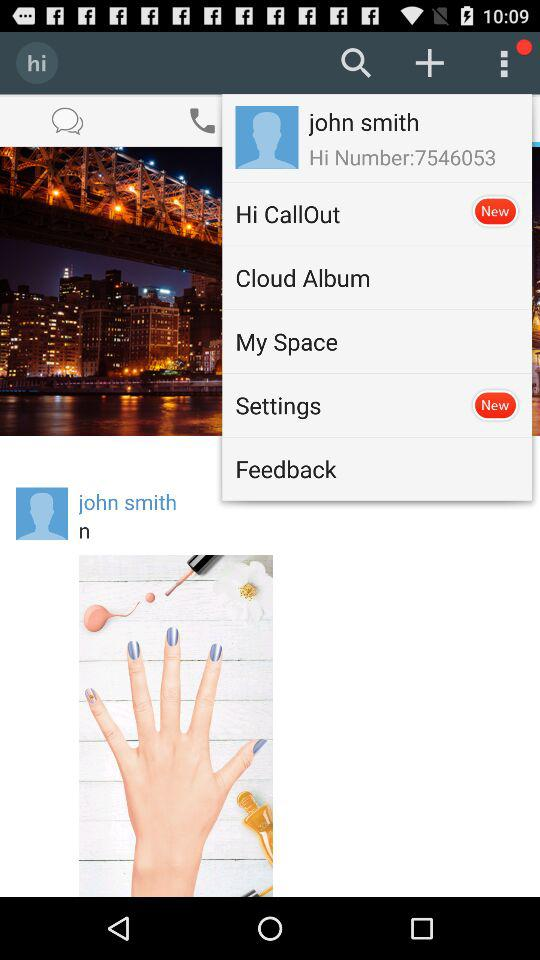What is the name of the user? The name of the user is John Smith. 